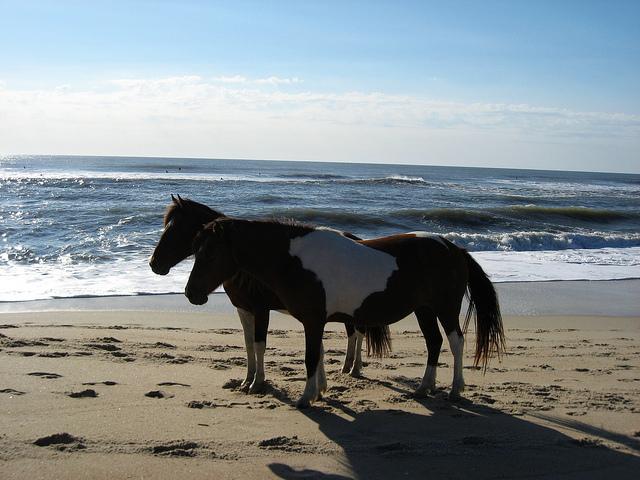Are the waves rough or calm?
Answer briefly. Calm. How many horses are there?
Be succinct. 2. What are the horses walking on?
Keep it brief. Sand. 